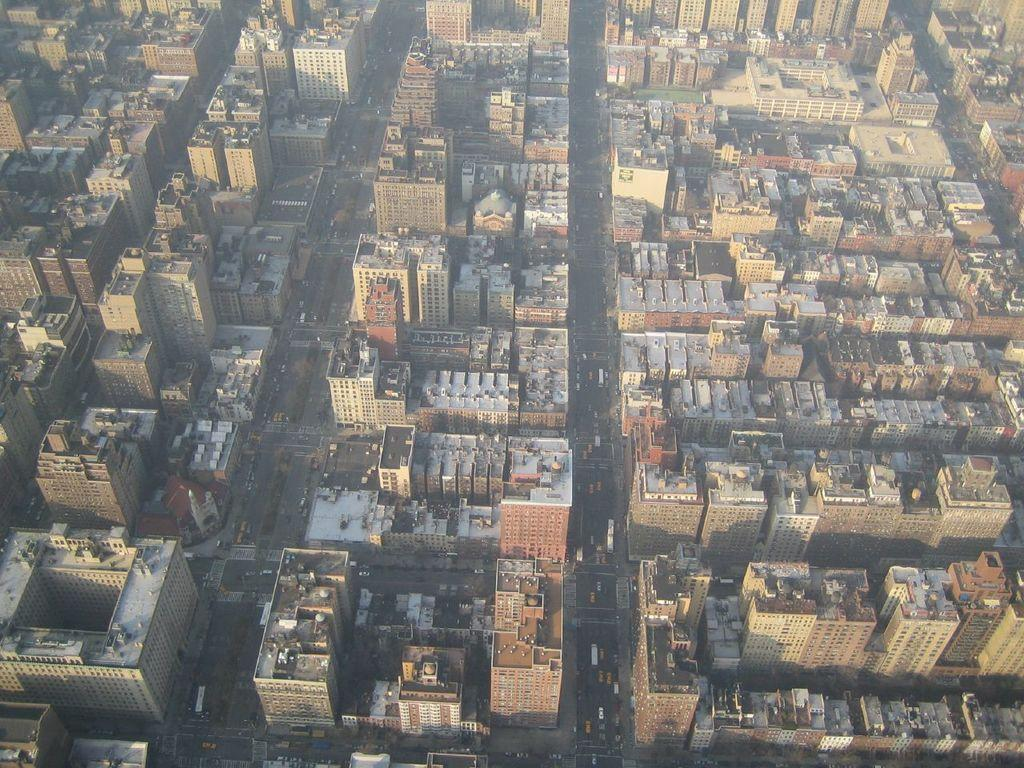What type of structures can be seen in the image? The image contains tall buildings. What can be seen between the buildings? There are roads visible in the image. What type of transportation might be using these roads? Vehicles are present in the image. Where is the alley with the bottle visible in the image? There is no alley or bottle present in the image. 